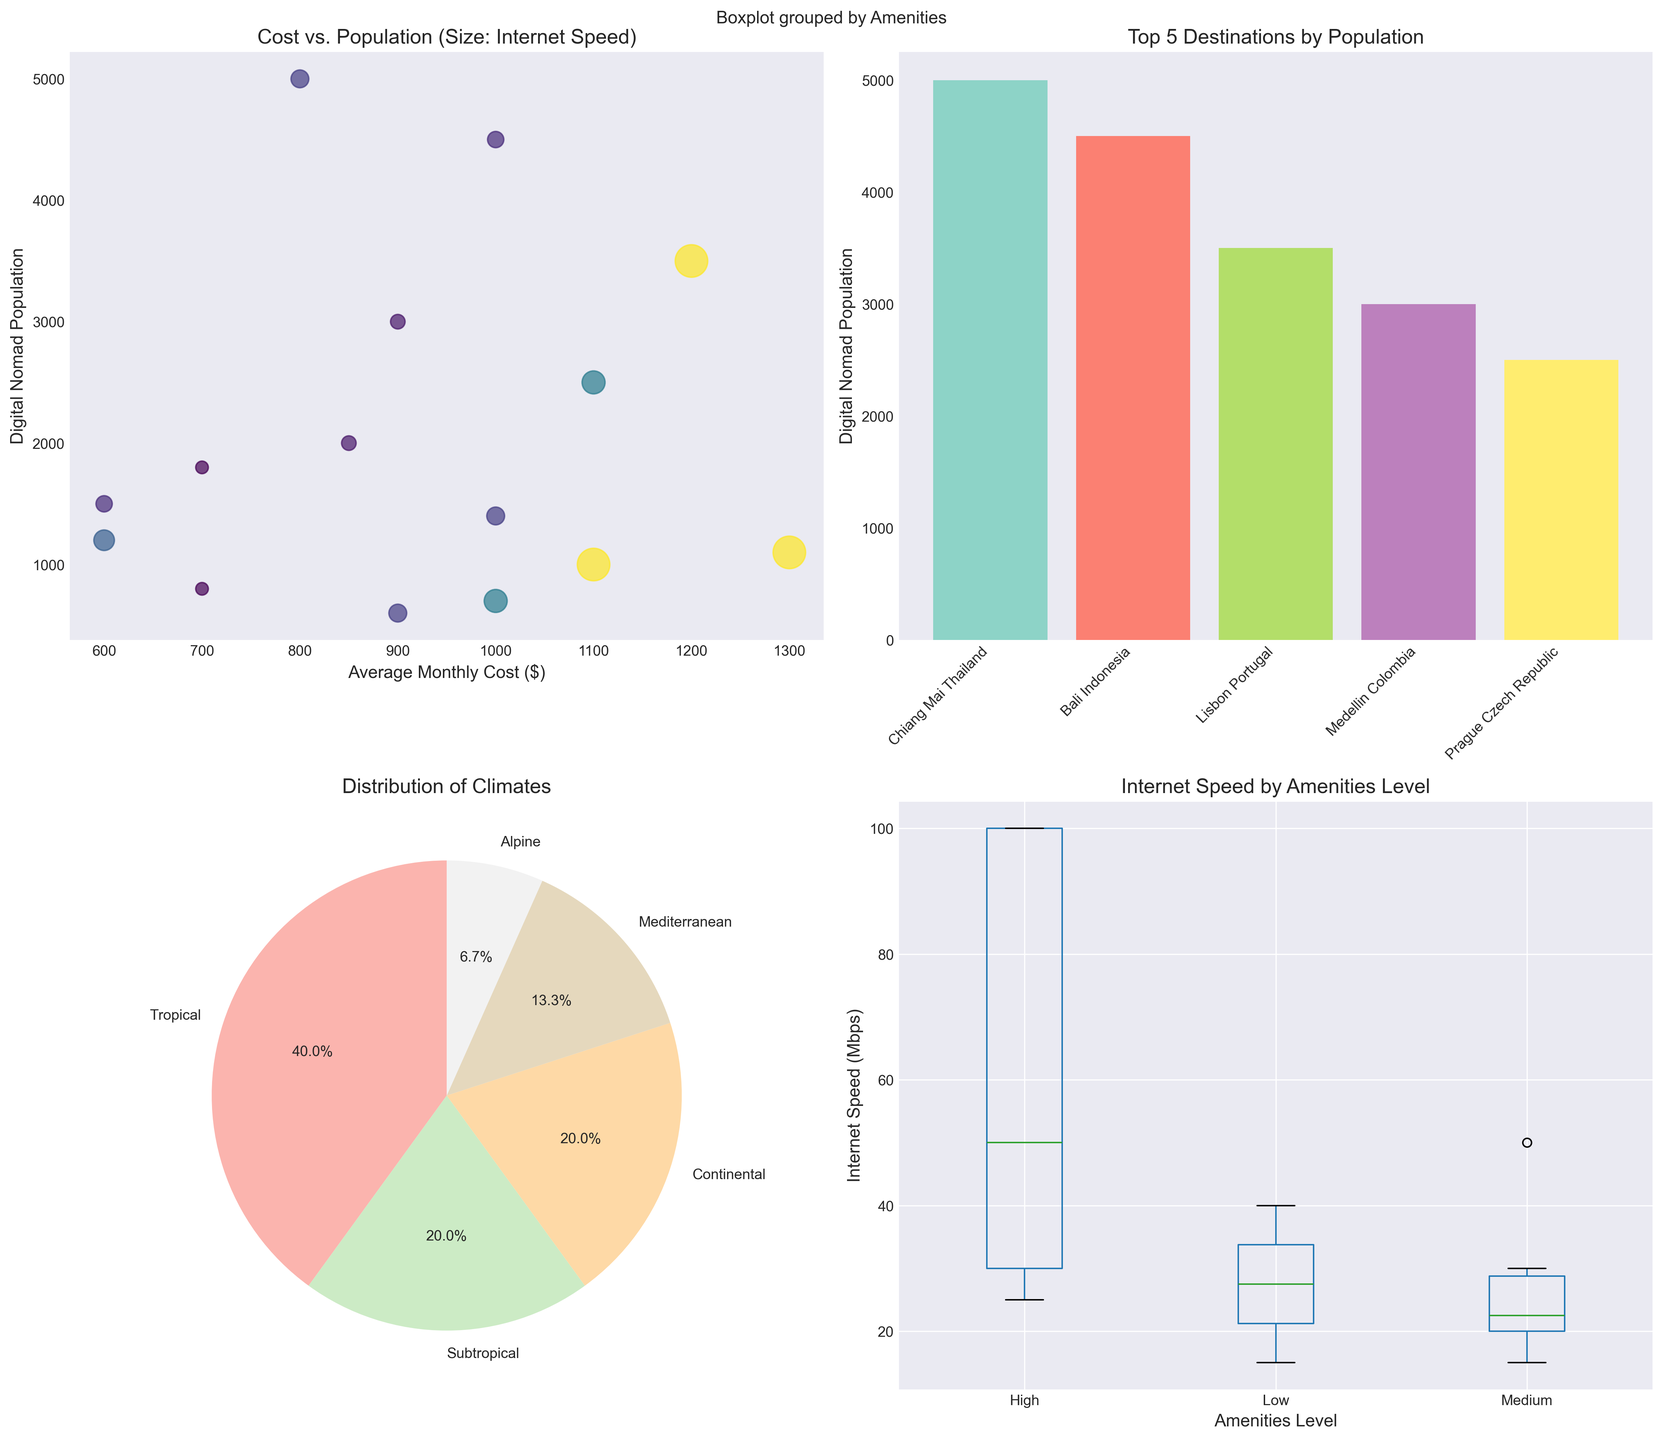What is the title of the scatter plot? The title is located at the top of the scatter plot within the first subplot. It reads "Cost vs. Population (Size: Internet Speed)".
Answer: Cost vs. Population (Size: Internet Speed) How many locations are represented in the pie chart for climate distribution? The pie chart represents categories of climates, and each segment corresponds to one climate type. Counting these segments, we find there are five different climate types.
Answer: 5 Which location has the highest digital nomad population according to the bar plot? The bar plot showing the top 5 destinations by population lists the locations on the x-axis. The tallest bar represents the highest population. This bar is labelled "Chiang Mai Thailand".
Answer: Chiang Mai Thailand What is the range of Internet Speed (Mbps) in locations with 'High' amenities according to the box plot? The box plot for Internet Speed by amenities displays separate boxes for each category. The box for 'High' amenities shows the range from the bottom whisker to the top whisker. The range is from the minimum at 30 Mbps to the maximum at 100 Mbps.
Answer: 30-100 Mbps Which climate represents the smallest segment in the pie chart? The pie chart displays the relative sizes of different climate segments. The smallest segment is labeled as "Alpine".
Answer: Alpine What is the difference in the average monthly cost between Lisbon Portugal and Da Nang Vietnam from the scatter plot? From the scatter plot, we look at the x-axis values for Lisbon Portugal and Da Nang Vietnam. Lisbon's cost is $1200, and Da Nang's cost is $600. The difference is $1200 - $600.
Answer: $600 Which location has the lowest digital nomad population in the top 5 bar plot? The bar plot indicates digital nomad populations of the top 5 locations. The shortest bar, representing the lowest population, is labeled "Lisbon Portugal".
Answer: Lisbon Portugal What percentage of locations have a tropical climate according to the pie chart? The pie chart shows the distribution of climates with percentage labels. By finding the label for "Tropical", we see it is 40.0%.
Answer: 40.0% What is the median Internet speed for locations with 'Medium' amenities according to the box plot? The box plot illustrates the distribution of Internet speeds for different amenities. For 'Medium' amenities, the median is indicated as the line inside the box. This line is at 20 Mbps.
Answer: 20 Mbps 